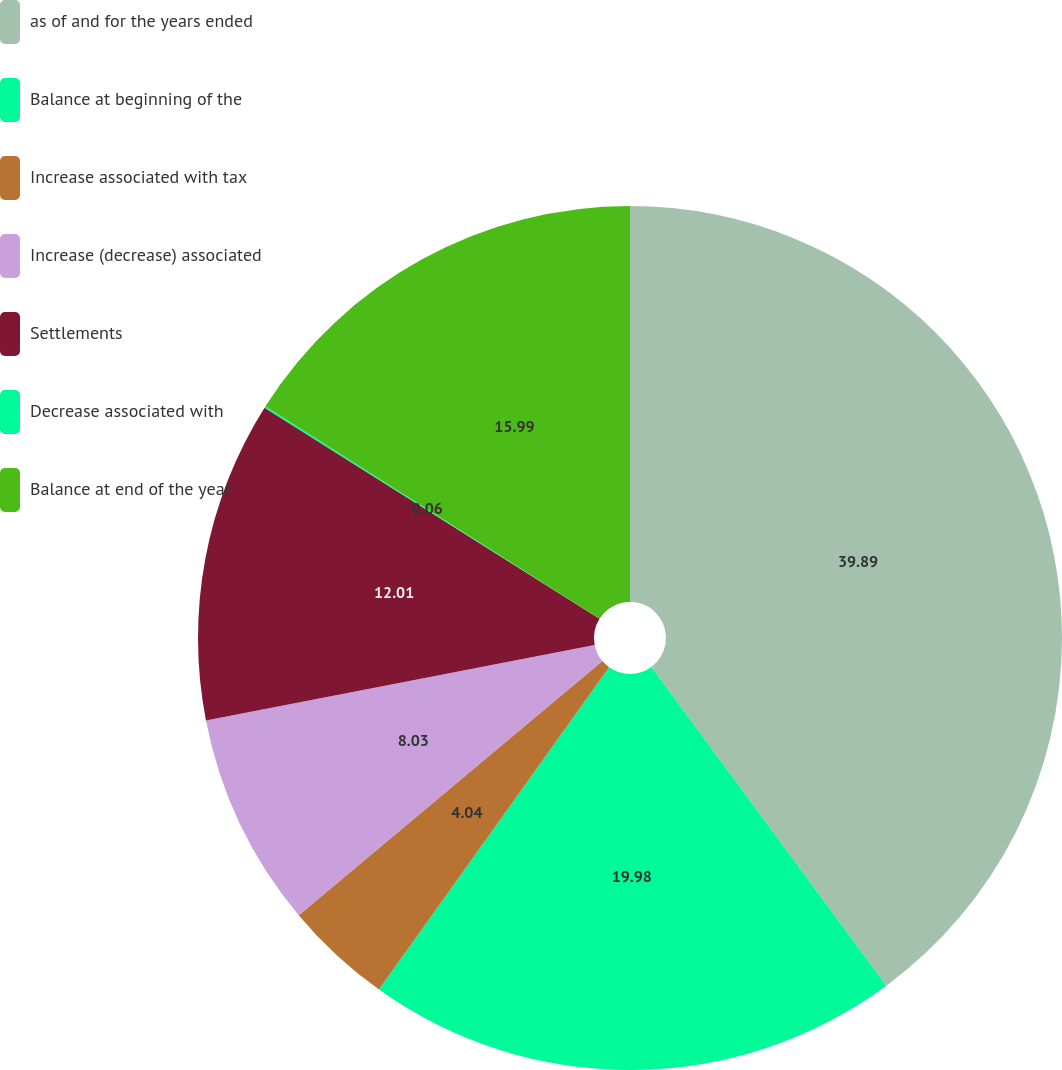Convert chart. <chart><loc_0><loc_0><loc_500><loc_500><pie_chart><fcel>as of and for the years ended<fcel>Balance at beginning of the<fcel>Increase associated with tax<fcel>Increase (decrease) associated<fcel>Settlements<fcel>Decrease associated with<fcel>Balance at end of the year<nl><fcel>39.89%<fcel>19.98%<fcel>4.04%<fcel>8.03%<fcel>12.01%<fcel>0.06%<fcel>15.99%<nl></chart> 